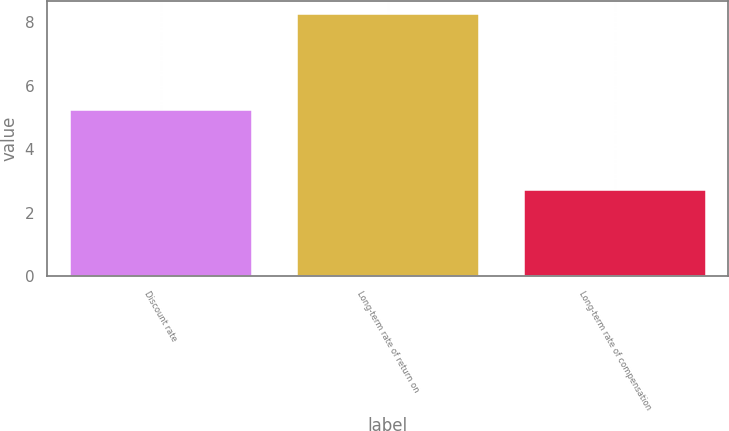Convert chart to OTSL. <chart><loc_0><loc_0><loc_500><loc_500><bar_chart><fcel>Discount rate<fcel>Long-term rate of return on<fcel>Long-term rate of compensation<nl><fcel>5.25<fcel>8.25<fcel>2.7<nl></chart> 